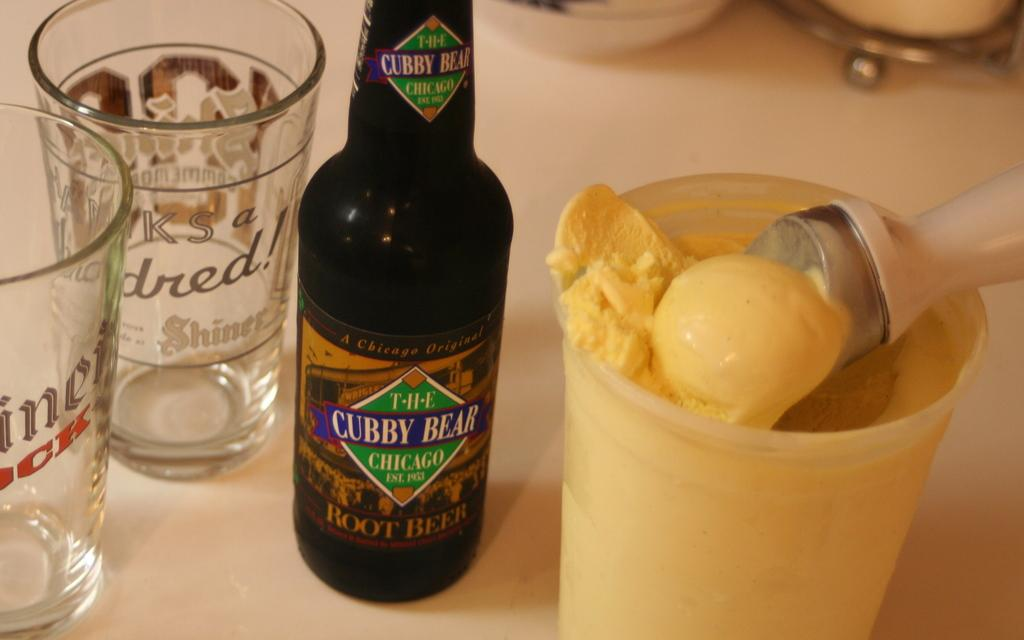Provide a one-sentence caption for the provided image. A black bottle of Cubby Bear beer sitting next to a bowl of vanilla ice cream. 